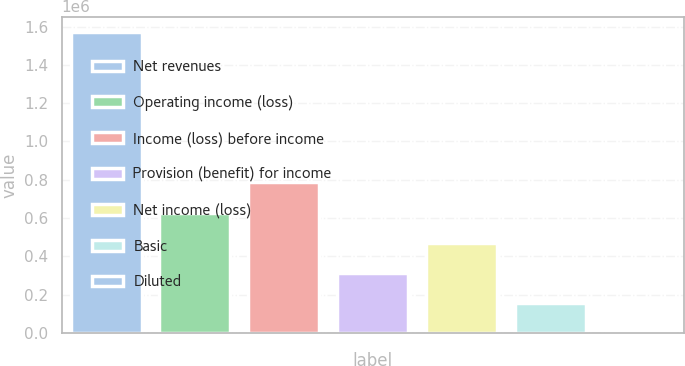Convert chart to OTSL. <chart><loc_0><loc_0><loc_500><loc_500><bar_chart><fcel>Net revenues<fcel>Operating income (loss)<fcel>Income (loss) before income<fcel>Provision (benefit) for income<fcel>Net income (loss)<fcel>Basic<fcel>Diluted<nl><fcel>1.57323e+06<fcel>629294<fcel>786617<fcel>314647<fcel>471970<fcel>157324<fcel>0.87<nl></chart> 